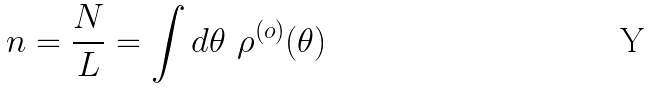Convert formula to latex. <formula><loc_0><loc_0><loc_500><loc_500>n = \frac { N } { L } = \int d \theta \ \rho ^ { ( o ) } ( \theta )</formula> 